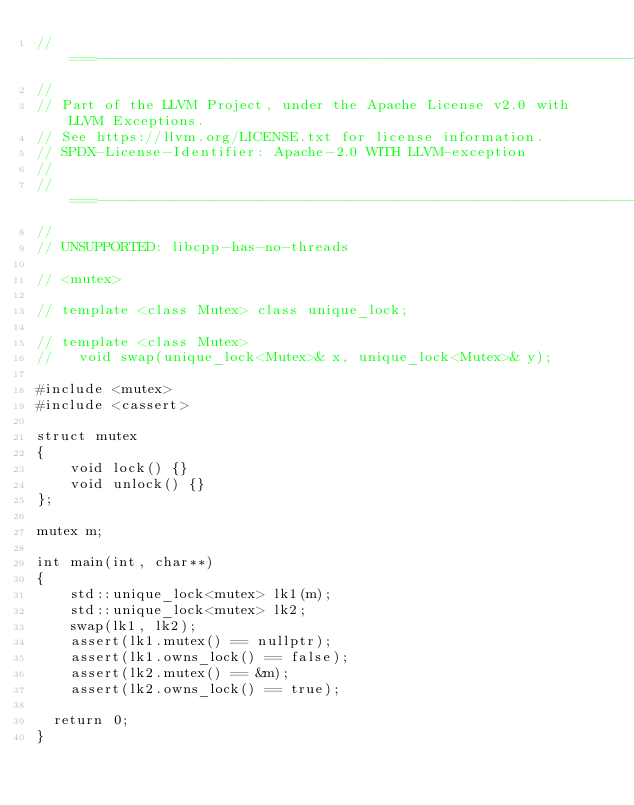<code> <loc_0><loc_0><loc_500><loc_500><_C++_>//===----------------------------------------------------------------------===//
//
// Part of the LLVM Project, under the Apache License v2.0 with LLVM Exceptions.
// See https://llvm.org/LICENSE.txt for license information.
// SPDX-License-Identifier: Apache-2.0 WITH LLVM-exception
//
//===----------------------------------------------------------------------===//
//
// UNSUPPORTED: libcpp-has-no-threads

// <mutex>

// template <class Mutex> class unique_lock;

// template <class Mutex>
//   void swap(unique_lock<Mutex>& x, unique_lock<Mutex>& y);

#include <mutex>
#include <cassert>

struct mutex
{
    void lock() {}
    void unlock() {}
};

mutex m;

int main(int, char**)
{
    std::unique_lock<mutex> lk1(m);
    std::unique_lock<mutex> lk2;
    swap(lk1, lk2);
    assert(lk1.mutex() == nullptr);
    assert(lk1.owns_lock() == false);
    assert(lk2.mutex() == &m);
    assert(lk2.owns_lock() == true);

  return 0;
}
</code> 